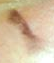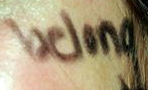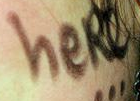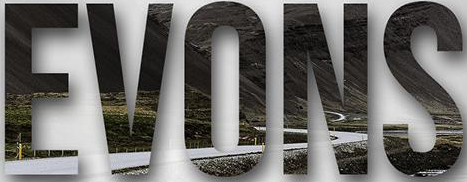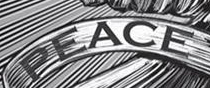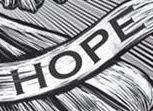What words can you see in these images in sequence, separated by a semicolon? I; belong; heRe; EVONS; PEACE; HOPE 